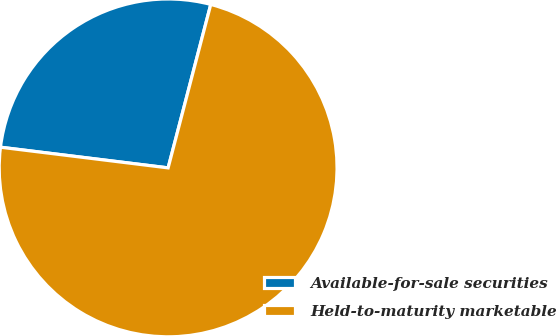Convert chart to OTSL. <chart><loc_0><loc_0><loc_500><loc_500><pie_chart><fcel>Available-for-sale securities<fcel>Held-to-maturity marketable<nl><fcel>27.11%<fcel>72.89%<nl></chart> 